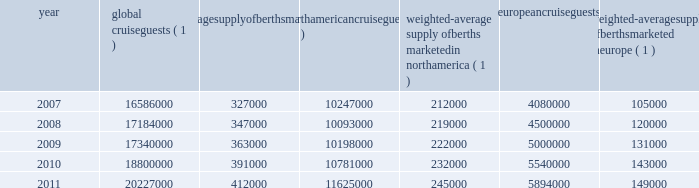Part i berths at the end of 2011 .
There are approximately 10 ships with an estimated 34000 berths that are expected to be placed in service in the north american cruise market between 2012 and 2016 .
Europe in europe , cruising represents a smaller but growing sector of the vacation industry .
It has experienced a compound annual growth rate in cruise guests of approximately 9.6% ( 9.6 % ) from 2007 to 2011 and we believe this market has significant continued growth poten- tial .
We estimate that europe was served by 104 ships with approximately 100000 berths at the beginning of 2007 and by 121 ships with approximately 155000 berths at the end of 2011 .
There are approximately 10 ships with an estimated 28000 berths that are expected to be placed in service in the european cruise market between 2012 and 2016 .
The table details the growth in the global , north american and european cruise markets in terms of cruise guests and estimated weighted-average berths over the past five years : global cruise guests ( 1 ) weighted-average supply of berths marketed globally ( 1 ) north american cruise guests ( 2 ) weighted-average supply of berths marketed in north america ( 1 ) european cruise guests ( 3 ) weighted-average supply of berths marketed in europe ( 1 ) .
( 1 ) source : our estimates of the number of global cruise guests , and the weighted-average supply of berths marketed globally , in north america and europe are based on a combination of data that we obtain from various publicly available cruise industry trade information sources including seatrade insider and cruise line international association .
In addition , our estimates incorporate our own statistical analysis utilizing the same publicly available cruise industry data as a base .
( 2 ) source : cruise line international association based on cruise guests carried for at least two consecutive nights for years 2007 through 2010 .
Year 2011 amounts represent our estimates ( see number 1 above ) .
( 3 ) source : european cruise council for years 2007 through 2010 .
Year 2011 amounts represent our estimates ( see number 1 above ) .
Other markets in addition to expected industry growth in north america and europe as discussed above , we expect the asia/pacific region to demonstrate an even higher growth rate in the near term , although it will continue to represent a relatively small sector compared to north america and europe .
We compete with a number of cruise lines ; however , our principal competitors are carnival corporation & plc , which owns , among others , aida cruises , carnival cruise lines , costa cruises , cunard line , holland america line , iberocruceros , p&o cruises and princess cruises ; disney cruise line ; msc cruises ; norwegian cruise line and oceania cruises .
Cruise lines compete with other vacation alternatives such as land-based resort hotels and sightseeing destinations for consum- ers 2019 leisure time .
Demand for such activities is influ- enced by political and general economic conditions .
Companies within the vacation market are dependent on consumer discretionary spending .
Operating strategies our principal operating strategies are to : and employees and protect the environment in which our vessels and organization operate , to better serve our global guest base and grow our business , order to enhance our revenues while continuing to expand and diversify our guest mix through interna- tional guest sourcing , and ensure adequate cash and liquidity , with the overall goal of maximizing our return on invested capital and long-term shareholder value , our brands throughout the world , revitalization of existing ships and the transfer of key innovations across each brand , while expanding our fleet with the new state-of-the-art cruise ships recently delivered and on order , by deploying them into those markets and itineraries that provide opportunities to optimize returns , while continuing our focus on existing key markets , support ongoing operations and initiatives , and the principal industry distribution channel , while enhancing our consumer outreach programs. .
What is the annual average of berths per ship , from 2012-2016 , that are expected to be placed in service in the north american cruise market? 
Computations: ((34000 / 10) / 4)
Answer: 850.0. Part i berths at the end of 2011 .
There are approximately 10 ships with an estimated 34000 berths that are expected to be placed in service in the north american cruise market between 2012 and 2016 .
Europe in europe , cruising represents a smaller but growing sector of the vacation industry .
It has experienced a compound annual growth rate in cruise guests of approximately 9.6% ( 9.6 % ) from 2007 to 2011 and we believe this market has significant continued growth poten- tial .
We estimate that europe was served by 104 ships with approximately 100000 berths at the beginning of 2007 and by 121 ships with approximately 155000 berths at the end of 2011 .
There are approximately 10 ships with an estimated 28000 berths that are expected to be placed in service in the european cruise market between 2012 and 2016 .
The table details the growth in the global , north american and european cruise markets in terms of cruise guests and estimated weighted-average berths over the past five years : global cruise guests ( 1 ) weighted-average supply of berths marketed globally ( 1 ) north american cruise guests ( 2 ) weighted-average supply of berths marketed in north america ( 1 ) european cruise guests ( 3 ) weighted-average supply of berths marketed in europe ( 1 ) .
( 1 ) source : our estimates of the number of global cruise guests , and the weighted-average supply of berths marketed globally , in north america and europe are based on a combination of data that we obtain from various publicly available cruise industry trade information sources including seatrade insider and cruise line international association .
In addition , our estimates incorporate our own statistical analysis utilizing the same publicly available cruise industry data as a base .
( 2 ) source : cruise line international association based on cruise guests carried for at least two consecutive nights for years 2007 through 2010 .
Year 2011 amounts represent our estimates ( see number 1 above ) .
( 3 ) source : european cruise council for years 2007 through 2010 .
Year 2011 amounts represent our estimates ( see number 1 above ) .
Other markets in addition to expected industry growth in north america and europe as discussed above , we expect the asia/pacific region to demonstrate an even higher growth rate in the near term , although it will continue to represent a relatively small sector compared to north america and europe .
We compete with a number of cruise lines ; however , our principal competitors are carnival corporation & plc , which owns , among others , aida cruises , carnival cruise lines , costa cruises , cunard line , holland america line , iberocruceros , p&o cruises and princess cruises ; disney cruise line ; msc cruises ; norwegian cruise line and oceania cruises .
Cruise lines compete with other vacation alternatives such as land-based resort hotels and sightseeing destinations for consum- ers 2019 leisure time .
Demand for such activities is influ- enced by political and general economic conditions .
Companies within the vacation market are dependent on consumer discretionary spending .
Operating strategies our principal operating strategies are to : and employees and protect the environment in which our vessels and organization operate , to better serve our global guest base and grow our business , order to enhance our revenues while continuing to expand and diversify our guest mix through interna- tional guest sourcing , and ensure adequate cash and liquidity , with the overall goal of maximizing our return on invested capital and long-term shareholder value , our brands throughout the world , revitalization of existing ships and the transfer of key innovations across each brand , while expanding our fleet with the new state-of-the-art cruise ships recently delivered and on order , by deploying them into those markets and itineraries that provide opportunities to optimize returns , while continuing our focus on existing key markets , support ongoing operations and initiatives , and the principal industry distribution channel , while enhancing our consumer outreach programs. .
What was the percentage increase in the global guests from 2007 to 2011? 
Computations: ((20227000 - 16586000) / 16586000)
Answer: 0.21952. 